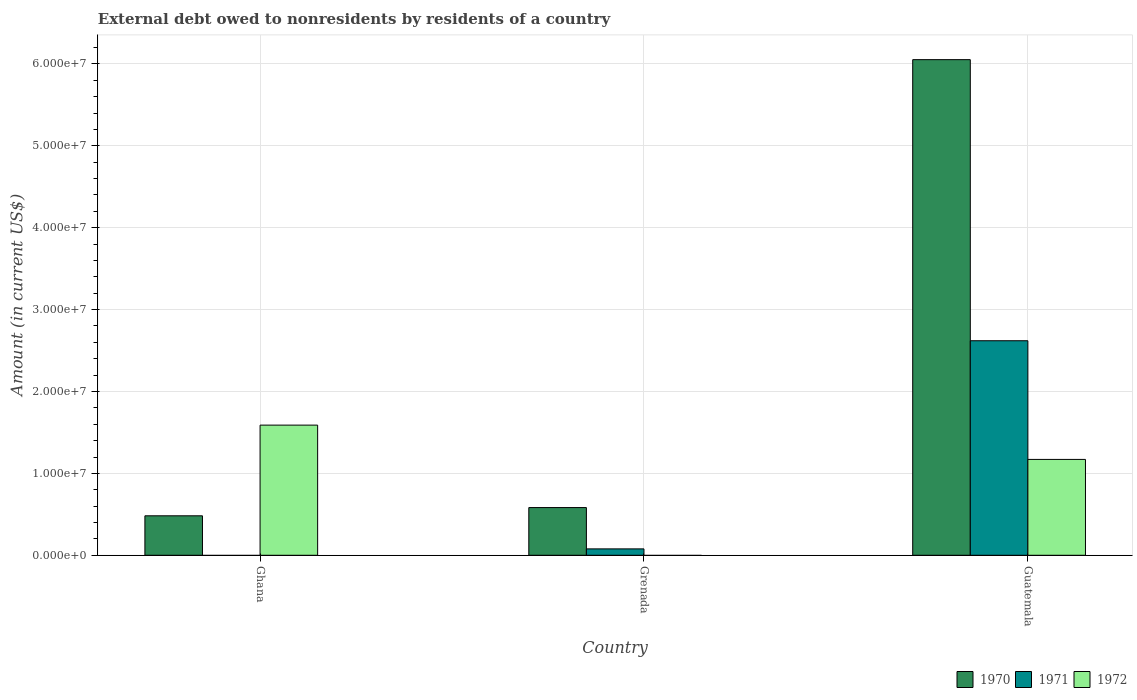Are the number of bars per tick equal to the number of legend labels?
Keep it short and to the point. No. What is the label of the 3rd group of bars from the left?
Offer a very short reply. Guatemala. What is the external debt owed by residents in 1970 in Ghana?
Ensure brevity in your answer.  4.82e+06. Across all countries, what is the maximum external debt owed by residents in 1970?
Provide a short and direct response. 6.05e+07. Across all countries, what is the minimum external debt owed by residents in 1970?
Your answer should be very brief. 4.82e+06. In which country was the external debt owed by residents in 1971 maximum?
Offer a very short reply. Guatemala. What is the total external debt owed by residents in 1972 in the graph?
Your response must be concise. 2.76e+07. What is the difference between the external debt owed by residents in 1971 in Grenada and that in Guatemala?
Make the answer very short. -2.54e+07. What is the difference between the external debt owed by residents in 1971 in Grenada and the external debt owed by residents in 1972 in Ghana?
Your answer should be very brief. -1.51e+07. What is the average external debt owed by residents in 1970 per country?
Offer a very short reply. 2.37e+07. What is the difference between the external debt owed by residents of/in 1971 and external debt owed by residents of/in 1972 in Guatemala?
Your answer should be very brief. 1.45e+07. What is the ratio of the external debt owed by residents in 1970 in Ghana to that in Guatemala?
Your response must be concise. 0.08. Is the external debt owed by residents in 1970 in Ghana less than that in Grenada?
Offer a terse response. Yes. What is the difference between the highest and the second highest external debt owed by residents in 1970?
Offer a terse response. 5.47e+07. What is the difference between the highest and the lowest external debt owed by residents in 1970?
Provide a short and direct response. 5.57e+07. Is the sum of the external debt owed by residents in 1972 in Ghana and Guatemala greater than the maximum external debt owed by residents in 1970 across all countries?
Offer a terse response. No. Is it the case that in every country, the sum of the external debt owed by residents in 1972 and external debt owed by residents in 1970 is greater than the external debt owed by residents in 1971?
Make the answer very short. Yes. Are all the bars in the graph horizontal?
Keep it short and to the point. No. How many countries are there in the graph?
Your answer should be very brief. 3. Does the graph contain grids?
Your response must be concise. Yes. Where does the legend appear in the graph?
Make the answer very short. Bottom right. What is the title of the graph?
Offer a terse response. External debt owed to nonresidents by residents of a country. What is the label or title of the X-axis?
Keep it short and to the point. Country. What is the label or title of the Y-axis?
Your response must be concise. Amount (in current US$). What is the Amount (in current US$) of 1970 in Ghana?
Offer a terse response. 4.82e+06. What is the Amount (in current US$) in 1972 in Ghana?
Your answer should be compact. 1.59e+07. What is the Amount (in current US$) of 1970 in Grenada?
Provide a succinct answer. 5.82e+06. What is the Amount (in current US$) of 1971 in Grenada?
Provide a succinct answer. 7.80e+05. What is the Amount (in current US$) of 1970 in Guatemala?
Keep it short and to the point. 6.05e+07. What is the Amount (in current US$) in 1971 in Guatemala?
Give a very brief answer. 2.62e+07. What is the Amount (in current US$) of 1972 in Guatemala?
Offer a very short reply. 1.17e+07. Across all countries, what is the maximum Amount (in current US$) in 1970?
Offer a terse response. 6.05e+07. Across all countries, what is the maximum Amount (in current US$) in 1971?
Your answer should be compact. 2.62e+07. Across all countries, what is the maximum Amount (in current US$) in 1972?
Offer a very short reply. 1.59e+07. Across all countries, what is the minimum Amount (in current US$) of 1970?
Your response must be concise. 4.82e+06. Across all countries, what is the minimum Amount (in current US$) of 1971?
Keep it short and to the point. 0. Across all countries, what is the minimum Amount (in current US$) of 1972?
Keep it short and to the point. 0. What is the total Amount (in current US$) in 1970 in the graph?
Your response must be concise. 7.12e+07. What is the total Amount (in current US$) in 1971 in the graph?
Your answer should be very brief. 2.70e+07. What is the total Amount (in current US$) in 1972 in the graph?
Offer a terse response. 2.76e+07. What is the difference between the Amount (in current US$) in 1970 in Ghana and that in Grenada?
Give a very brief answer. -1.01e+06. What is the difference between the Amount (in current US$) in 1970 in Ghana and that in Guatemala?
Your answer should be compact. -5.57e+07. What is the difference between the Amount (in current US$) in 1972 in Ghana and that in Guatemala?
Offer a terse response. 4.19e+06. What is the difference between the Amount (in current US$) in 1970 in Grenada and that in Guatemala?
Your response must be concise. -5.47e+07. What is the difference between the Amount (in current US$) of 1971 in Grenada and that in Guatemala?
Your answer should be very brief. -2.54e+07. What is the difference between the Amount (in current US$) of 1970 in Ghana and the Amount (in current US$) of 1971 in Grenada?
Provide a short and direct response. 4.04e+06. What is the difference between the Amount (in current US$) in 1970 in Ghana and the Amount (in current US$) in 1971 in Guatemala?
Offer a terse response. -2.14e+07. What is the difference between the Amount (in current US$) of 1970 in Ghana and the Amount (in current US$) of 1972 in Guatemala?
Your answer should be very brief. -6.89e+06. What is the difference between the Amount (in current US$) in 1970 in Grenada and the Amount (in current US$) in 1971 in Guatemala?
Offer a very short reply. -2.04e+07. What is the difference between the Amount (in current US$) in 1970 in Grenada and the Amount (in current US$) in 1972 in Guatemala?
Ensure brevity in your answer.  -5.88e+06. What is the difference between the Amount (in current US$) in 1971 in Grenada and the Amount (in current US$) in 1972 in Guatemala?
Offer a terse response. -1.09e+07. What is the average Amount (in current US$) of 1970 per country?
Ensure brevity in your answer.  2.37e+07. What is the average Amount (in current US$) in 1971 per country?
Offer a very short reply. 8.99e+06. What is the average Amount (in current US$) in 1972 per country?
Your answer should be compact. 9.20e+06. What is the difference between the Amount (in current US$) of 1970 and Amount (in current US$) of 1972 in Ghana?
Provide a succinct answer. -1.11e+07. What is the difference between the Amount (in current US$) of 1970 and Amount (in current US$) of 1971 in Grenada?
Ensure brevity in your answer.  5.04e+06. What is the difference between the Amount (in current US$) of 1970 and Amount (in current US$) of 1971 in Guatemala?
Your response must be concise. 3.43e+07. What is the difference between the Amount (in current US$) in 1970 and Amount (in current US$) in 1972 in Guatemala?
Your answer should be compact. 4.88e+07. What is the difference between the Amount (in current US$) of 1971 and Amount (in current US$) of 1972 in Guatemala?
Provide a succinct answer. 1.45e+07. What is the ratio of the Amount (in current US$) in 1970 in Ghana to that in Grenada?
Provide a succinct answer. 0.83. What is the ratio of the Amount (in current US$) in 1970 in Ghana to that in Guatemala?
Your response must be concise. 0.08. What is the ratio of the Amount (in current US$) in 1972 in Ghana to that in Guatemala?
Offer a terse response. 1.36. What is the ratio of the Amount (in current US$) of 1970 in Grenada to that in Guatemala?
Keep it short and to the point. 0.1. What is the ratio of the Amount (in current US$) in 1971 in Grenada to that in Guatemala?
Offer a terse response. 0.03. What is the difference between the highest and the second highest Amount (in current US$) in 1970?
Keep it short and to the point. 5.47e+07. What is the difference between the highest and the lowest Amount (in current US$) of 1970?
Offer a very short reply. 5.57e+07. What is the difference between the highest and the lowest Amount (in current US$) in 1971?
Provide a succinct answer. 2.62e+07. What is the difference between the highest and the lowest Amount (in current US$) of 1972?
Your answer should be compact. 1.59e+07. 